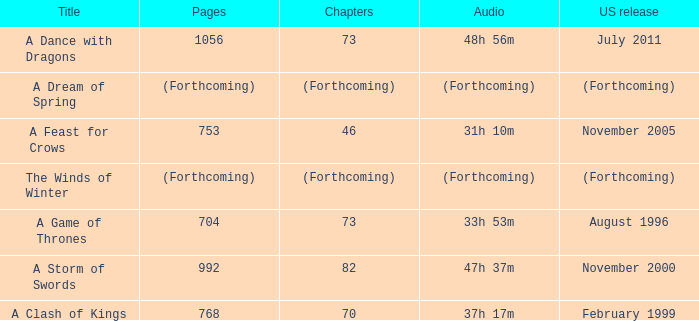How many pages does a dream of spring have? (Forthcoming). 